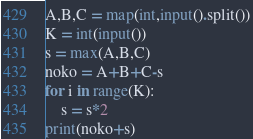Convert code to text. <code><loc_0><loc_0><loc_500><loc_500><_Python_>A,B,C = map(int,input().split())
K = int(input())
s = max(A,B,C)
noko = A+B+C-s
for i in range(K):
    s = s*2
print(noko+s)</code> 